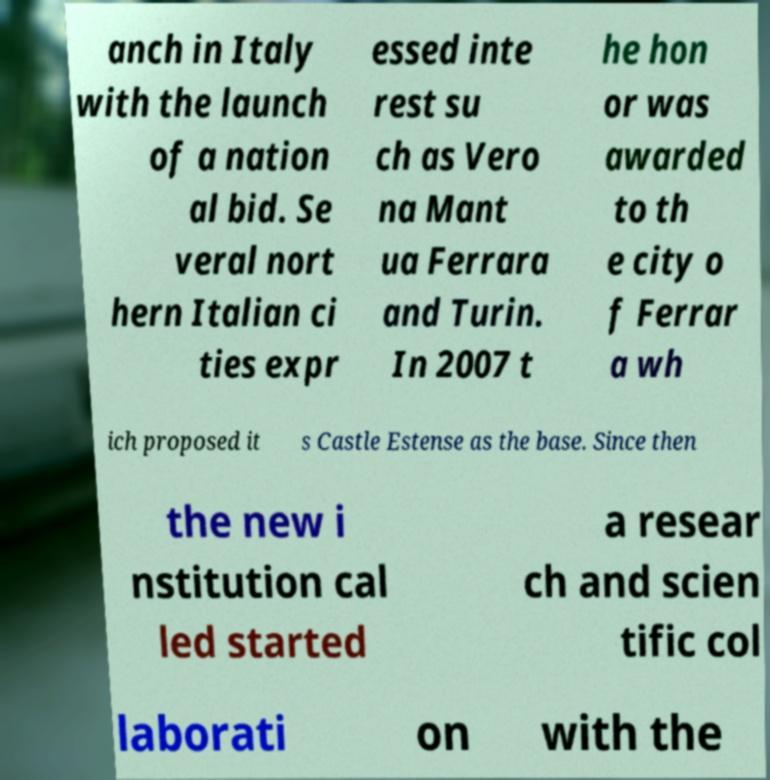Could you assist in decoding the text presented in this image and type it out clearly? anch in Italy with the launch of a nation al bid. Se veral nort hern Italian ci ties expr essed inte rest su ch as Vero na Mant ua Ferrara and Turin. In 2007 t he hon or was awarded to th e city o f Ferrar a wh ich proposed it s Castle Estense as the base. Since then the new i nstitution cal led started a resear ch and scien tific col laborati on with the 